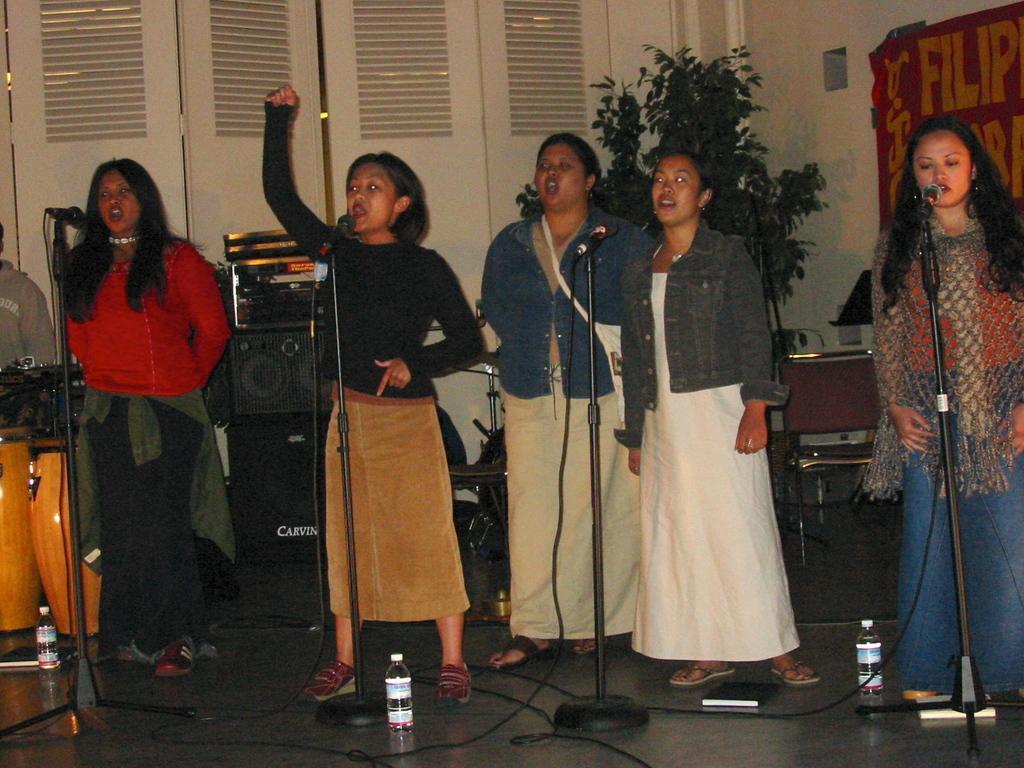Please provide a concise description of this image. In this picture there are four women standing and singing in front of a mic and there is another woman standing behind them and there are few speakers,musical instruments,a plant and a door in the background. 